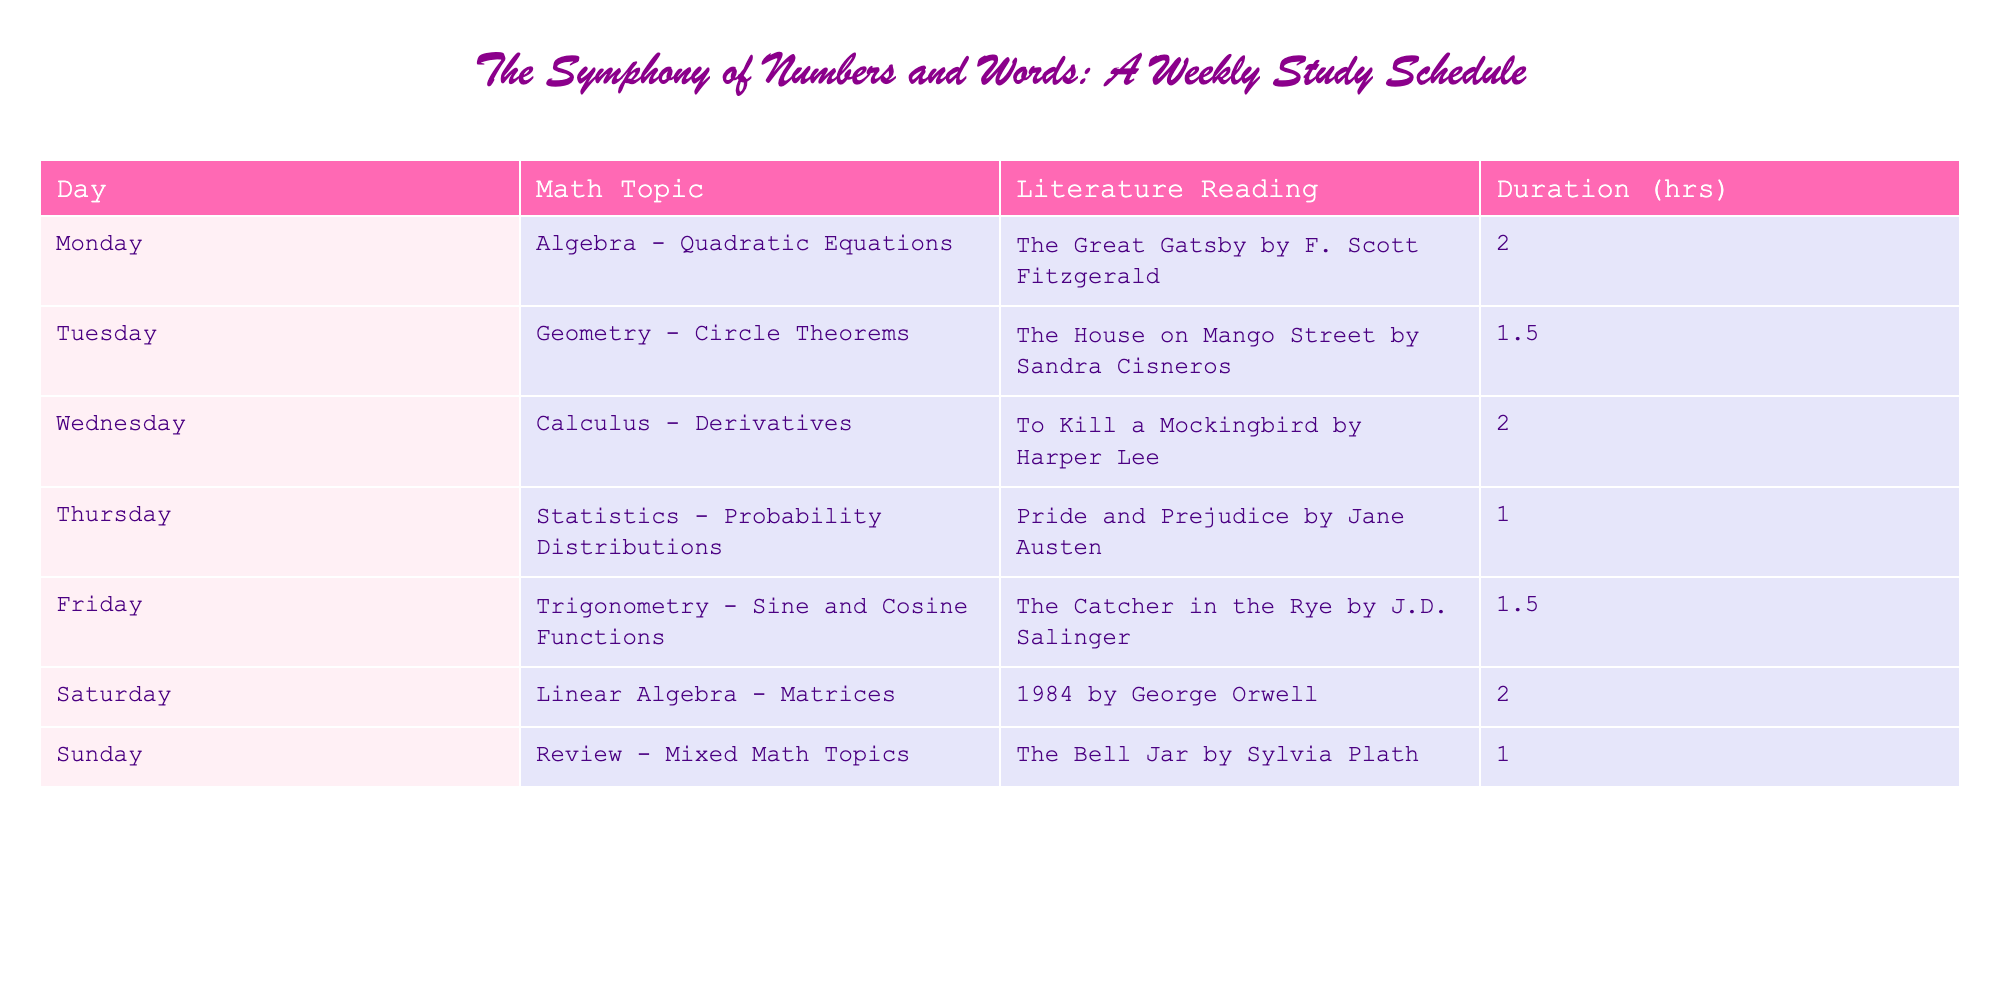What is the total duration of math study on weekends? To find the total duration of math study on weekends, we need to add the durations for Saturday and Sunday. On Saturday, the duration is 2 hours, and on Sunday, it is 1 hour. So, 2 + 1 = 3 hours.
Answer: 3 hours Which literature reading is paired with Calculus on Wednesday? The table shows that on Wednesday, the math topic is Calculus, and the paired literature reading is "To Kill a Mockingbird by Harper Lee."
Answer: "To Kill a Mockingbird by Harper Lee" Is the duration of literature reading shorter than the duration of math study on Tuesday? On Tuesday, the duration of math study is 1.5 hours, and the literature reading duration is also 1.5 hours. Since both are equal, the statement is false.
Answer: No What is the average duration of math study for the week? To calculate the average duration, first sum all the durations: 2 + 1.5 + 2 + 1 + 1.5 + 2 + 1 = 11 hours. There are 7 days, so the average is 11/7, which is approximately 1.57 hours.
Answer: 1.57 hours On which day is Linear Algebra taught, and what is its paired literature reading? Linear Algebra is taught on Saturday, and it is paired with the literature reading "1984 by George Orwell."
Answer: Saturday, "1984 by George Orwell" How many literature readings take 2 hours or more? By checking the durations of literature readings, only the readings paired with Algebra and Calculus take 2 hours. Thus, there are 2 literature readings that take 2 hours or more.
Answer: 2 Is there a day of the week where the literature reading is shorter than 1 hour? By examining the table, all literature readings have durations of 1 hour or more, with the shortest being 1 hour. Therefore, there is no day with a literature reading shorter than 1 hour.
Answer: No What is the total math study duration from Monday to Friday? To find the total math study duration from Monday to Friday, we add the durations for each day: 2 + 1.5 + 2 + 1 + 1.5 = 8 hours.
Answer: 8 hours Which literature reading has the shortest duration, and what day is it scheduled? Upon checking the table, the literature reading with the shortest duration is "The Bell Jar by Sylvia Plath," scheduled for Sunday with a duration of 1 hour.
Answer: "The Bell Jar by Sylvia Plath," Sunday 